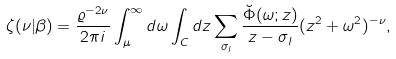<formula> <loc_0><loc_0><loc_500><loc_500>\zeta ( \nu | \beta ) = \frac { \varrho ^ { - 2 \nu } } { 2 \pi i } \int _ { \mu } ^ { \infty } d \omega \int _ { C } d z \sum _ { \sigma _ { l } } \frac { \breve { \Phi } ( \omega ; z ) } { z - \sigma _ { l } } ( z ^ { 2 } + \omega ^ { 2 } ) ^ { - \nu } ,</formula> 